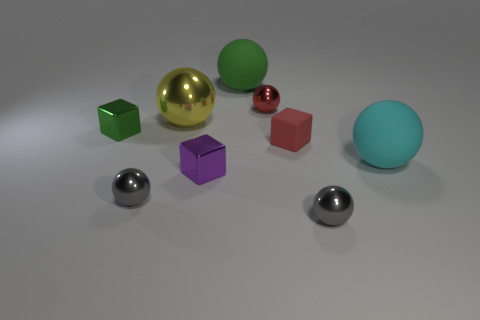There is a metallic block behind the cyan ball; how many tiny matte things are behind it?
Offer a terse response. 0. What size is the ball that is left of the tiny purple block and in front of the large cyan rubber sphere?
Provide a short and direct response. Small. Is the number of small cyan cylinders greater than the number of red spheres?
Offer a terse response. No. Is there a large thing of the same color as the rubber block?
Provide a short and direct response. No. There is a shiny block that is in front of the green metallic object; is it the same size as the cyan matte sphere?
Your answer should be very brief. No. Is the number of blue balls less than the number of tiny shiny balls?
Your answer should be compact. Yes. Is there another small purple cube made of the same material as the purple cube?
Your answer should be compact. No. There is a small shiny thing behind the small green shiny object; what is its shape?
Provide a succinct answer. Sphere. Is the color of the small cube to the right of the tiny purple object the same as the big shiny sphere?
Ensure brevity in your answer.  No. Are there fewer purple shiny blocks behind the big yellow ball than tiny things?
Give a very brief answer. Yes. 